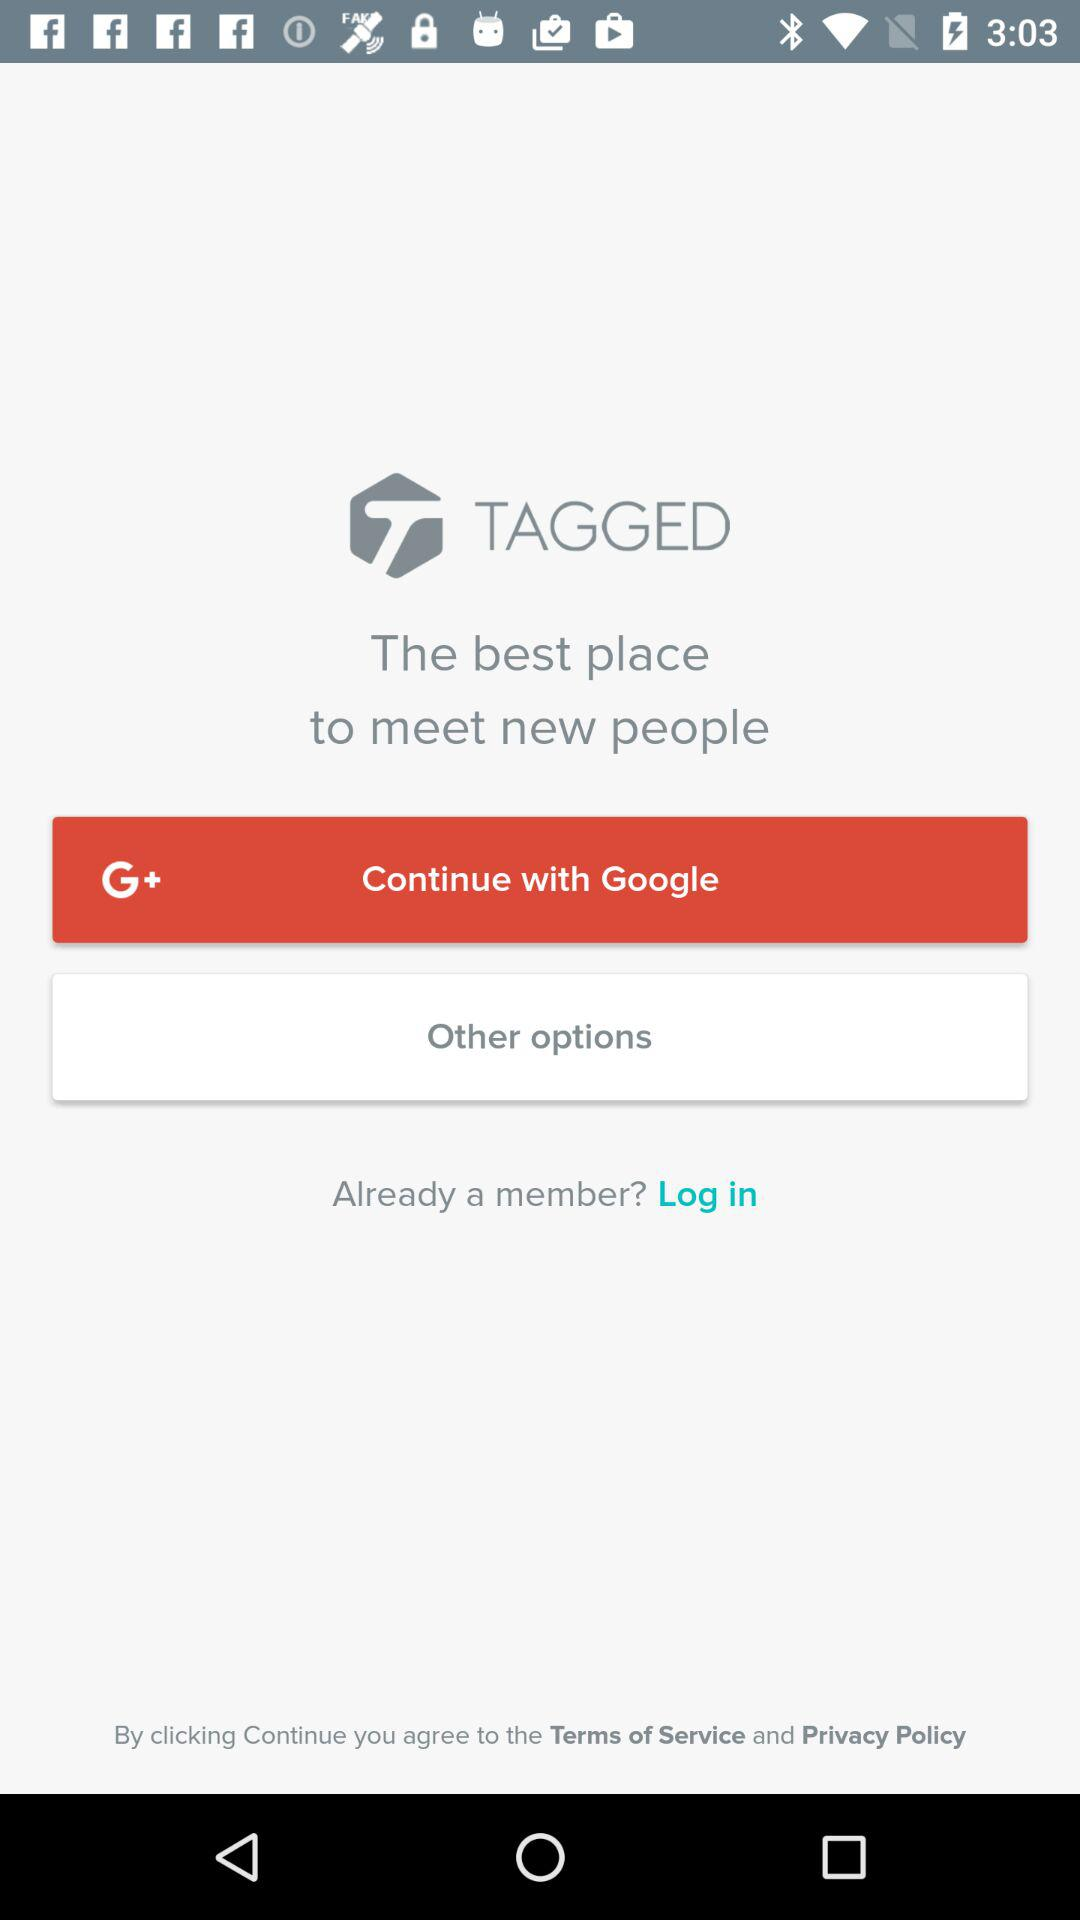Through what app can we log in? You can log in with "Google". 